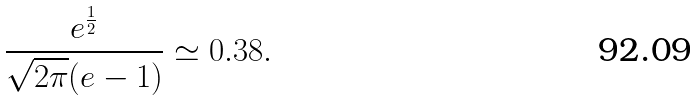Convert formula to latex. <formula><loc_0><loc_0><loc_500><loc_500>\frac { e ^ { \frac { 1 } { 2 } } } { \sqrt { 2 \pi } ( e - 1 ) } \simeq 0 . 3 8 .</formula> 